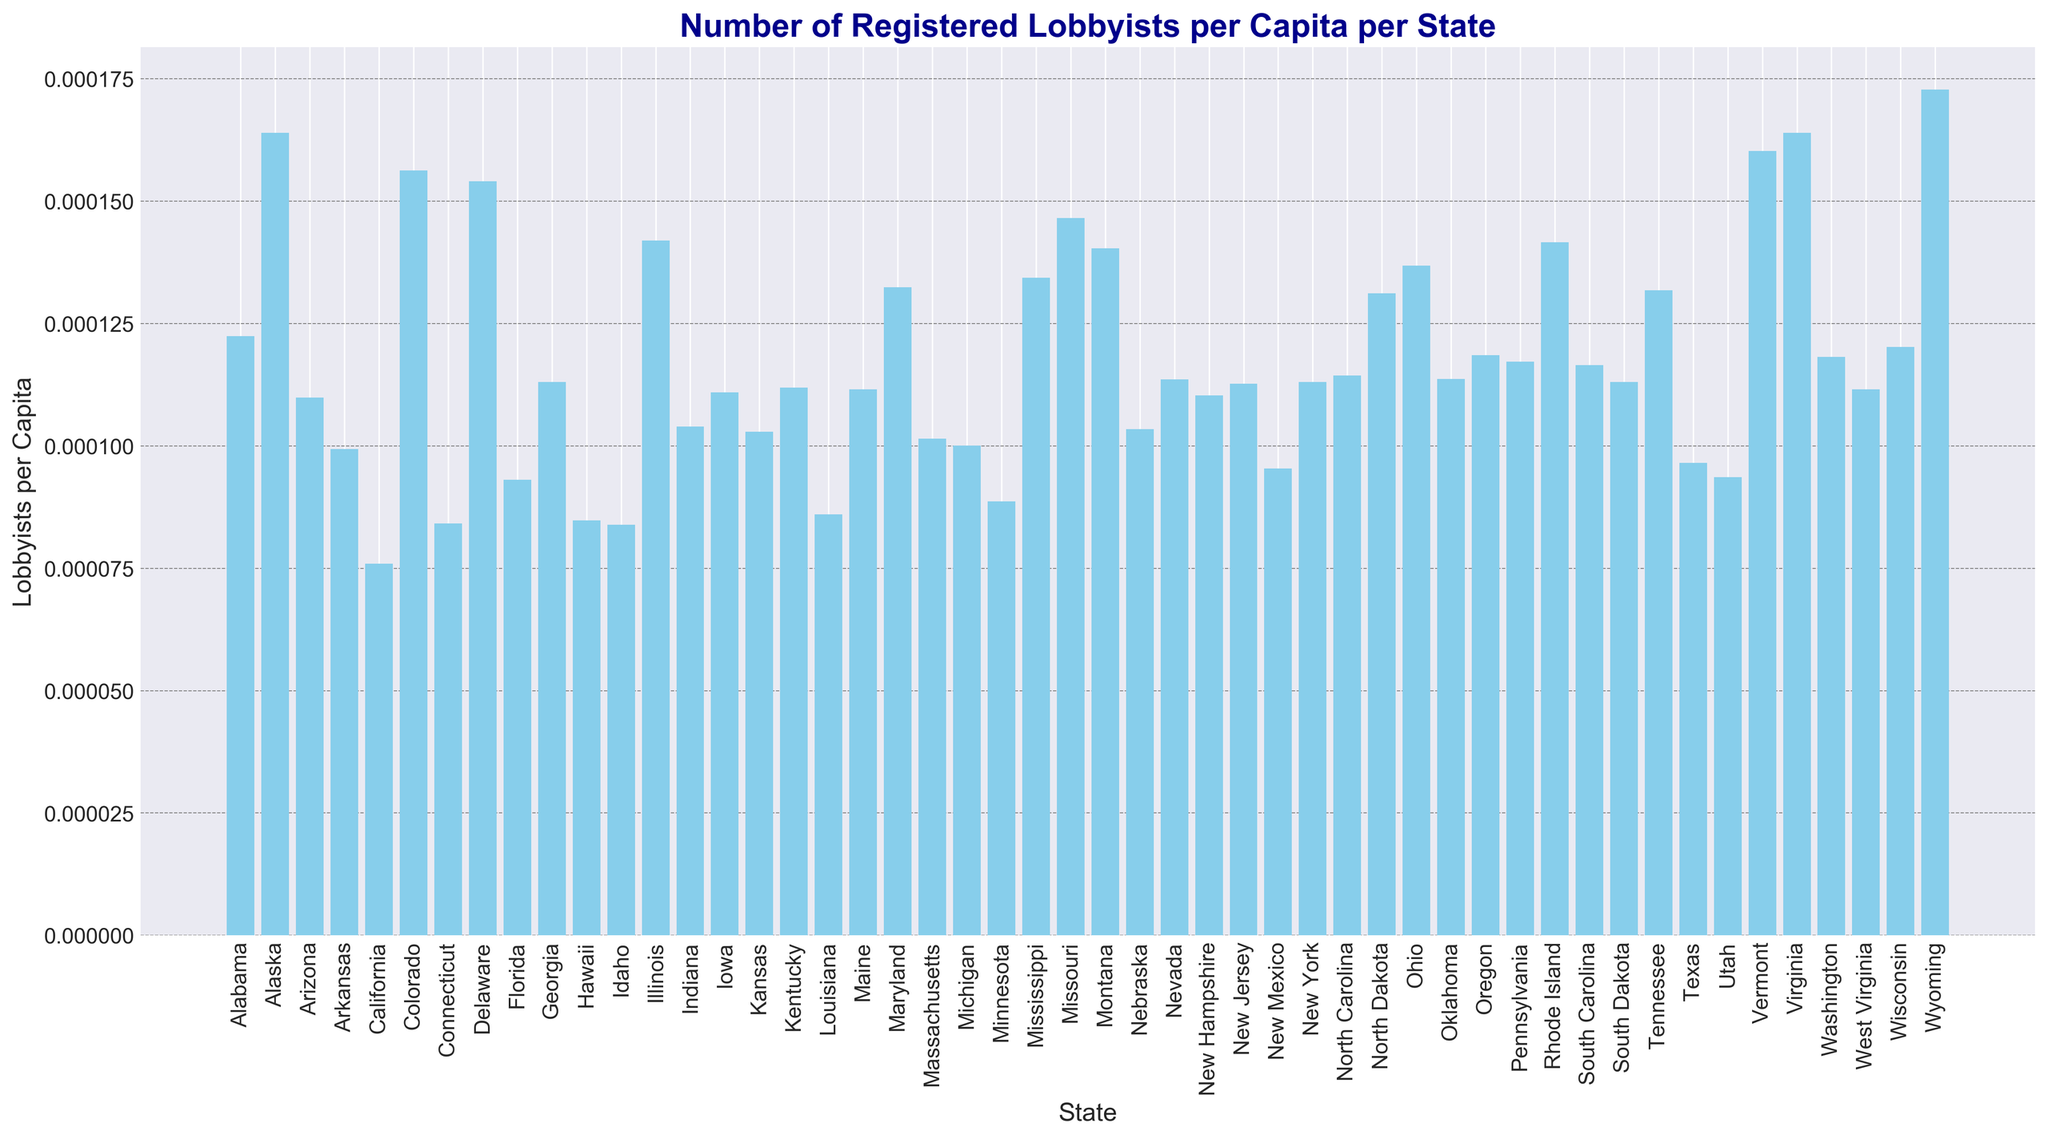Which state has the highest number of registered lobbyists per capita? The figure shows the bar heights representing the number of registered lobbyists per capita for each state. The tallest bar corresponds to Wyoming.
Answer: Wyoming Which state has the lowest number of registered lobbyists per capita? By examining the figure, the shortest bar is for California.
Answer: California How does Alabama compare to Florida in terms of registered lobbyists per capita? Looking at the relative heights of the bars, Alabama's bar is slightly taller than Florida’s. This indicates that Alabama has a higher number of registered lobbyists per capita than Florida.
Answer: Alabama has more What is the average number of registered lobbyists per capita for the top 3 states? The top 3 states with the highest lobbyists per capita are Wyoming, Alaska, and Virginia. Their values are approximately 0.0001728, 0.000164, and 0.000164, respectively. The average is (0.0001728 + 0.000164 + 0.000164) / 3 ≈ 0.0001669.
Answer: 0.0001669 Which state has more lobbyists per capita: Texas or New York? Comparing the bars, New York’s bar is taller than Texas's.
Answer: New York Are there more states with registered lobbyists per capita above 0.0001 or below 0.0001? Counting the bars, there are more states with registered lobbyists per capita above 0.0001.
Answer: Above 0.0001 What's the difference in registered lobbyists per capita between Georgia and North Carolina? Georgia’s bar shows approximately 0.0001131 while North Carolina’s bar shows approximately 0.0001144. The difference is 0.0001144 - 0.0001131 = 0.0000013.
Answer: 0.0000013 Which state has the closest number of registered lobbyists per capita to the national average (mean) value? First, calculate the average of all the states by summing up the lobbyists per capita and dividing by the number of states. Then, find the state bar closest to this value. Rhode Island is closest to the calculated average.
Answer: Rhode Island Does Virginia have more registered lobbyists per capita than Colorado? The bar representing Virginia is slightly taller than the bar representing Colorado, indicating that Virginia has more lobbyists per capita than Colorado.
Answer: Yes 